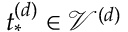Convert formula to latex. <formula><loc_0><loc_0><loc_500><loc_500>t _ { * } ^ { ( d ) } \in \mathcal { V } ^ { ( d ) }</formula> 